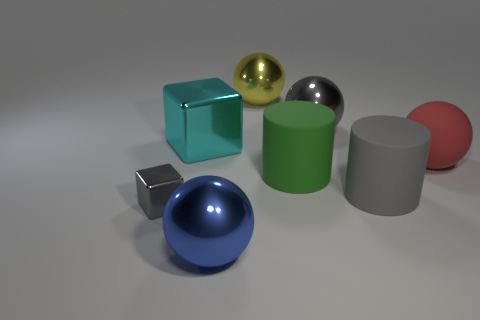Do the tiny cube and the big shiny block have the same color?
Your answer should be very brief. No. There is a sphere left of the yellow metal thing; is it the same color as the large rubber ball?
Your answer should be compact. No. There is a metal thing that is the same color as the small metallic block; what shape is it?
Give a very brief answer. Sphere. What number of cylinders are made of the same material as the cyan cube?
Make the answer very short. 0. How many large things are on the right side of the large green rubber cylinder?
Your answer should be very brief. 3. How big is the red sphere?
Offer a very short reply. Large. What color is the rubber ball that is the same size as the green object?
Your answer should be very brief. Red. Are there any other shiny cubes of the same color as the small metal block?
Your answer should be very brief. No. What is the green thing made of?
Keep it short and to the point. Rubber. What number of big purple matte things are there?
Give a very brief answer. 0. 